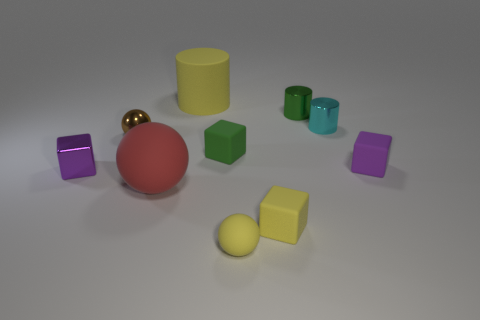How many objects are there, and can you describe their colors and shapes? There are nine objects in total. Their colors are purple, gold, red, light green, dark green, yellow, and cyan. The shapes include cubes, cylinders, and spheres, showcasing a variety of geometric forms.  Are there more cubes than spheres? Yes, there are more cubes than spheres. In the image, there are four cubes, three spheres, and two cylinders. 